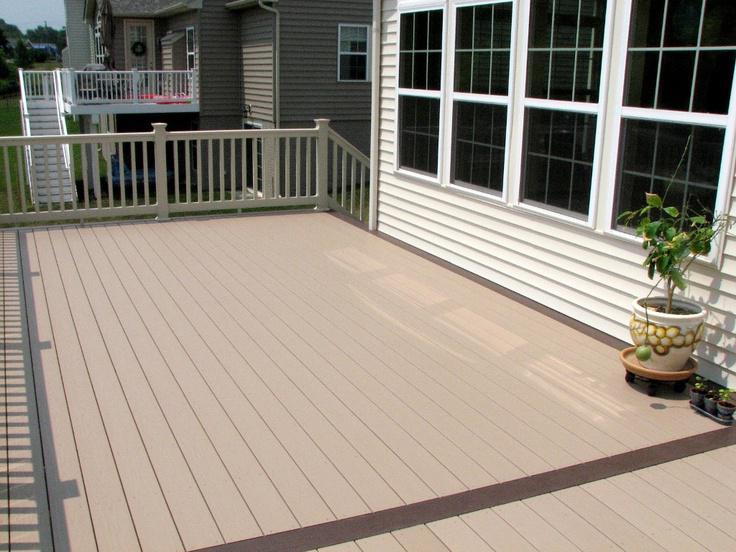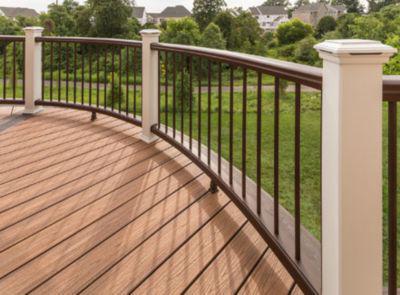The first image is the image on the left, the second image is the image on the right. Analyze the images presented: Is the assertion "One of the railings is black and white." valid? Answer yes or no. No. The first image is the image on the left, the second image is the image on the right. Assess this claim about the two images: "A wooden deck has bright white rails with black balusters.". Correct or not? Answer yes or no. No. 